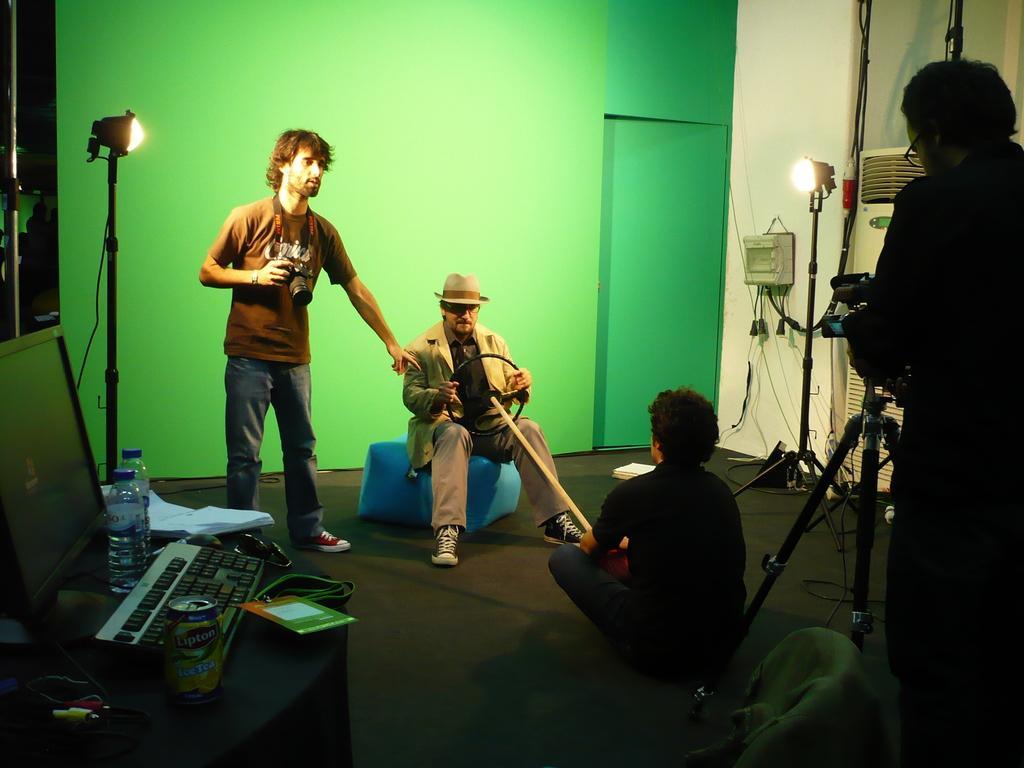Could you give a brief overview of what you see in this image? In this image I can see four people where the middle two are sitting and the rest two are standing. In the front I can see a table and on it I can see few bottles, a can, a keyboard, a monitor, few wires and few other things. In the background I can see few lights, few poles and a tripod stand on the right side of this image. 